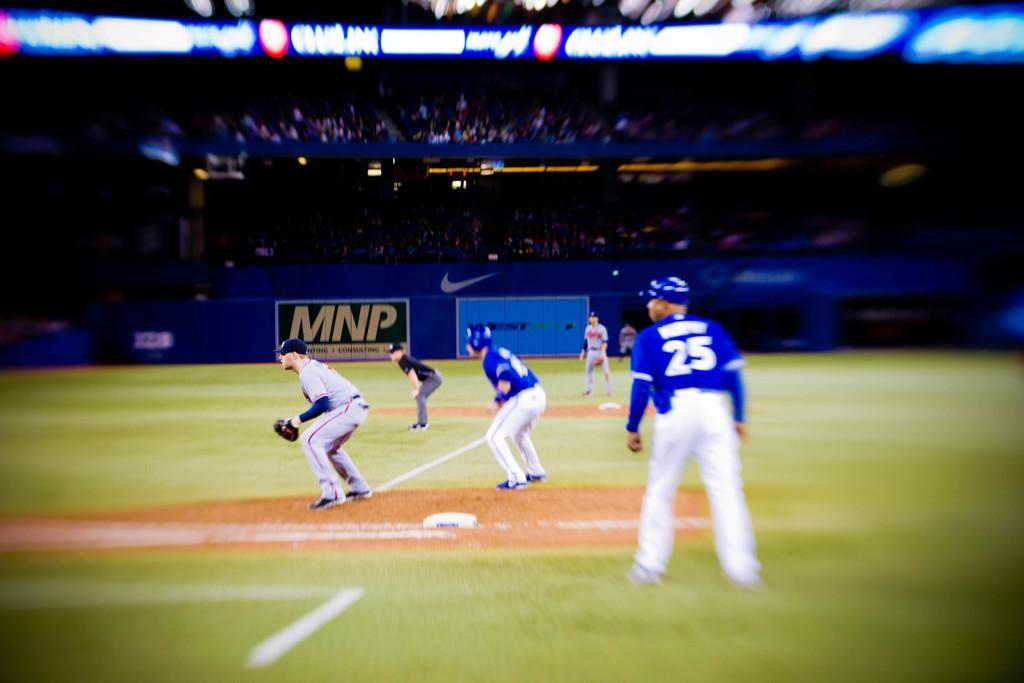<image>
Summarize the visual content of the image. a player with the number 25 on the back of their jersey 